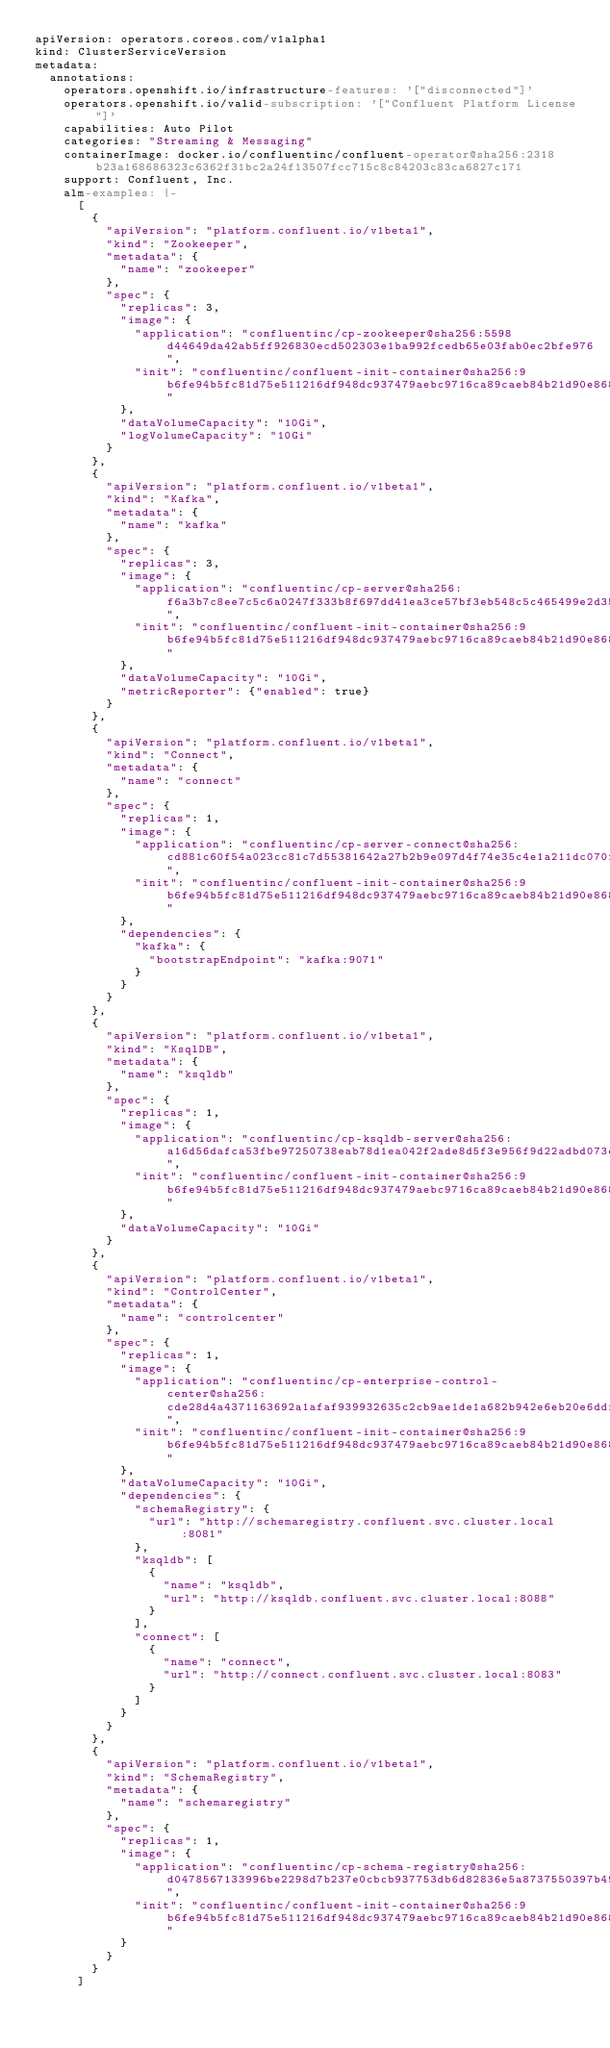<code> <loc_0><loc_0><loc_500><loc_500><_YAML_>apiVersion: operators.coreos.com/v1alpha1
kind: ClusterServiceVersion
metadata:
  annotations:
    operators.openshift.io/infrastructure-features: '["disconnected"]'
    operators.openshift.io/valid-subscription: '["Confluent Platform License"]'
    capabilities: Auto Pilot
    categories: "Streaming & Messaging"
    containerImage: docker.io/confluentinc/confluent-operator@sha256:2318b23a168686323c6362f31bc2a24f13507fcc715c8c84203c83ca6827c171
    support: Confluent, Inc.
    alm-examples: |-
      [
        {
          "apiVersion": "platform.confluent.io/v1beta1",
          "kind": "Zookeeper",
          "metadata": {
            "name": "zookeeper"
          },
          "spec": {
            "replicas": 3,
            "image": {
              "application": "confluentinc/cp-zookeeper@sha256:5598d44649da42ab5ff926830ecd502303e1ba992fcedb65e03fab0ec2bfe976",
              "init": "confluentinc/confluent-init-container@sha256:9b6fe94b5fc81d75e511216df948dc937479aebc9716ca89caeb84b21d90e868"
            },
            "dataVolumeCapacity": "10Gi",
            "logVolumeCapacity": "10Gi"
          }
        },
        {
          "apiVersion": "platform.confluent.io/v1beta1",
          "kind": "Kafka",
          "metadata": {
            "name": "kafka"
          },
          "spec": {
            "replicas": 3,
            "image": {
              "application": "confluentinc/cp-server@sha256:f6a3b7c8ee7c5c6a0247f333b8f697dd41ea3ce57bf3eb548c5c465499e2d350",
              "init": "confluentinc/confluent-init-container@sha256:9b6fe94b5fc81d75e511216df948dc937479aebc9716ca89caeb84b21d90e868"
            },
            "dataVolumeCapacity": "10Gi",
            "metricReporter": {"enabled": true}
          }
        },
        {
          "apiVersion": "platform.confluent.io/v1beta1",
          "kind": "Connect",
          "metadata": {
            "name": "connect"
          },
          "spec": {
            "replicas": 1,
            "image": {
              "application": "confluentinc/cp-server-connect@sha256:cd881c60f54a023cc81c7d55381642a27b2b9e097d4f74e35c4e1a211dc070f7",
              "init": "confluentinc/confluent-init-container@sha256:9b6fe94b5fc81d75e511216df948dc937479aebc9716ca89caeb84b21d90e868"
            },
            "dependencies": {
              "kafka": {
                "bootstrapEndpoint": "kafka:9071"
              }
            }
          }
        },
        {
          "apiVersion": "platform.confluent.io/v1beta1",
          "kind": "KsqlDB",
          "metadata": {
            "name": "ksqldb"
          },
          "spec": {
            "replicas": 1,
            "image": {
              "application": "confluentinc/cp-ksqldb-server@sha256:a16d56dafca53fbe97250738eab78d1ea042f2ade8d5f3e956f9d22adbd073e3",
              "init": "confluentinc/confluent-init-container@sha256:9b6fe94b5fc81d75e511216df948dc937479aebc9716ca89caeb84b21d90e868"
            },
            "dataVolumeCapacity": "10Gi"
          }
        },
        {
          "apiVersion": "platform.confluent.io/v1beta1",
          "kind": "ControlCenter",
          "metadata": {
            "name": "controlcenter"
          },
          "spec": {
            "replicas": 1,
            "image": {
              "application": "confluentinc/cp-enterprise-control-center@sha256:cde28d4a4371163692a1afaf939932635c2cb9ae1de1a682b942e6eb20e6ddf9",
              "init": "confluentinc/confluent-init-container@sha256:9b6fe94b5fc81d75e511216df948dc937479aebc9716ca89caeb84b21d90e868"
            },
            "dataVolumeCapacity": "10Gi",
            "dependencies": {
              "schemaRegistry": {
                "url": "http://schemaregistry.confluent.svc.cluster.local:8081"
              },
              "ksqldb": [
                {
                  "name": "ksqldb",
                  "url": "http://ksqldb.confluent.svc.cluster.local:8088"
                }
              ],
              "connect": [
                {
                  "name": "connect",
                  "url": "http://connect.confluent.svc.cluster.local:8083"
                }
              ]
            }
          }
        },
        {
          "apiVersion": "platform.confluent.io/v1beta1",
          "kind": "SchemaRegistry",
          "metadata": {
            "name": "schemaregistry"
          },
          "spec": {
            "replicas": 1,
            "image": {
              "application": "confluentinc/cp-schema-registry@sha256:d0478567133996be2298d7b237e0cbcb937753db6d82836e5a8737550397b493",
              "init": "confluentinc/confluent-init-container@sha256:9b6fe94b5fc81d75e511216df948dc937479aebc9716ca89caeb84b21d90e868"
            }
          }
        }
      ]</code> 